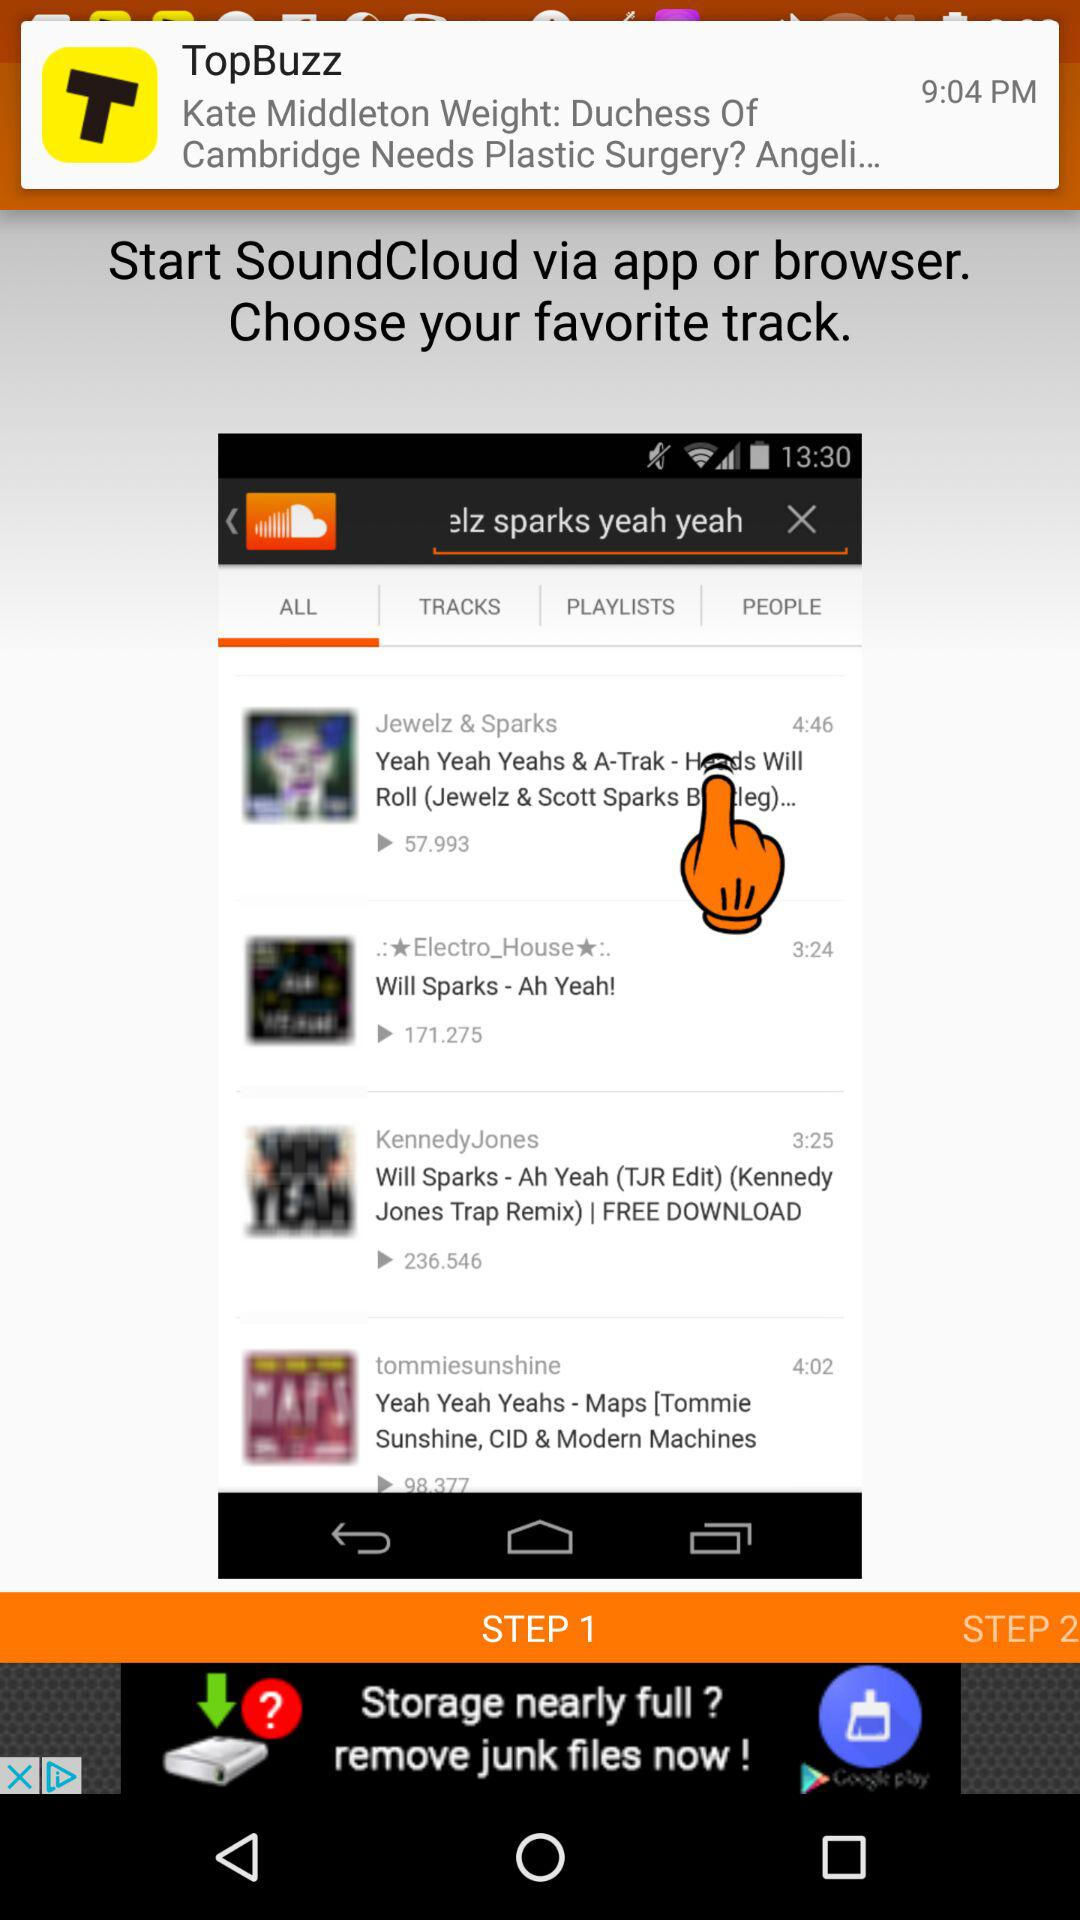How many plays in total does the video "Will Sparks - Ah Yeah!" get? There are 171.275 plays on the video "Will Sparks - Ah Yeah!". 